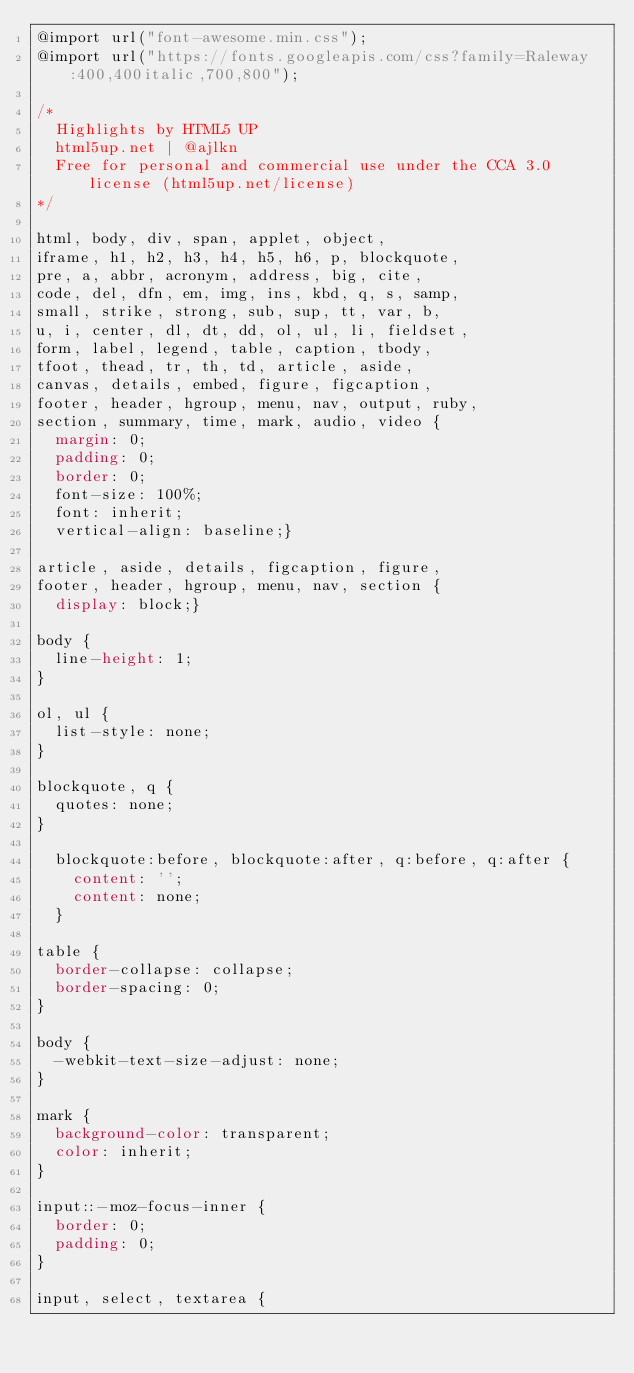<code> <loc_0><loc_0><loc_500><loc_500><_CSS_>@import url("font-awesome.min.css");
@import url("https://fonts.googleapis.com/css?family=Raleway:400,400italic,700,800");

/*
	Highlights by HTML5 UP
	html5up.net | @ajlkn
	Free for personal and commercial use under the CCA 3.0 license (html5up.net/license)
*/

html, body, div, span, applet, object,
iframe, h1, h2, h3, h4, h5, h6, p, blockquote,
pre, a, abbr, acronym, address, big, cite,
code, del, dfn, em, img, ins, kbd, q, s, samp,
small, strike, strong, sub, sup, tt, var, b,
u, i, center, dl, dt, dd, ol, ul, li, fieldset,
form, label, legend, table, caption, tbody,
tfoot, thead, tr, th, td, article, aside,
canvas, details, embed, figure, figcaption,
footer, header, hgroup, menu, nav, output, ruby,
section, summary, time, mark, audio, video {
	margin: 0;
	padding: 0;
	border: 0;
	font-size: 100%;
	font: inherit;
	vertical-align: baseline;}

article, aside, details, figcaption, figure,
footer, header, hgroup, menu, nav, section {
	display: block;}

body {
	line-height: 1;
}

ol, ul {
	list-style: none;
}

blockquote, q {
	quotes: none;
}

	blockquote:before, blockquote:after, q:before, q:after {
		content: '';
		content: none;
	}

table {
	border-collapse: collapse;
	border-spacing: 0;
}

body {
	-webkit-text-size-adjust: none;
}

mark {
	background-color: transparent;
	color: inherit;
}

input::-moz-focus-inner {
	border: 0;
	padding: 0;
}

input, select, textarea {</code> 